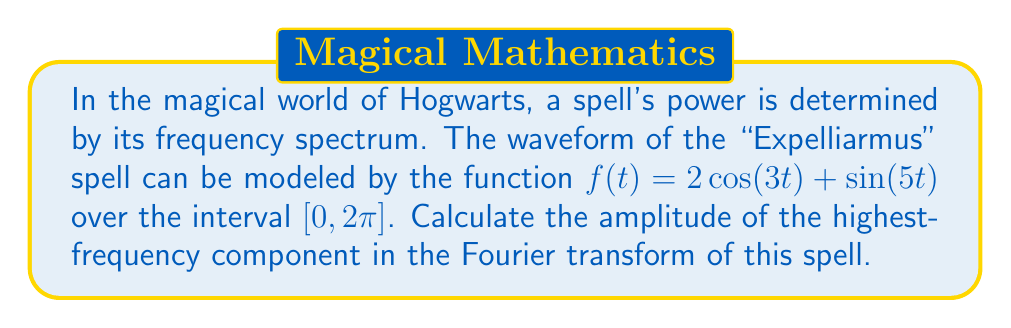Give your solution to this math problem. To analyze the frequency spectrum of the "Expelliarmus" spell using Fourier transforms, we'll follow these steps:

1) The given function $f(t) = 2\cos(3t) + \sin(5t)$ is already expressed as a sum of sinusoids, which is the form of a Fourier series.

2) In the Fourier transform, each sinusoid corresponds to a specific frequency component. The frequency of each component is determined by the coefficient of $t$ in the trigonometric function.

3) In this case, we have two components:
   - $2\cos(3t)$ with frequency 3
   - $\sin(5t)$ with frequency 5

4) The highest frequency component is $\sin(5t)$ with a frequency of 5.

5) The amplitude of a sinusoid in a Fourier series is given by the coefficient in front of the trigonometric function. For $\sin(5t)$, this coefficient is 1.

Therefore, the amplitude of the highest-frequency component in the Fourier transform of the "Expelliarmus" spell is 1.
Answer: 1 